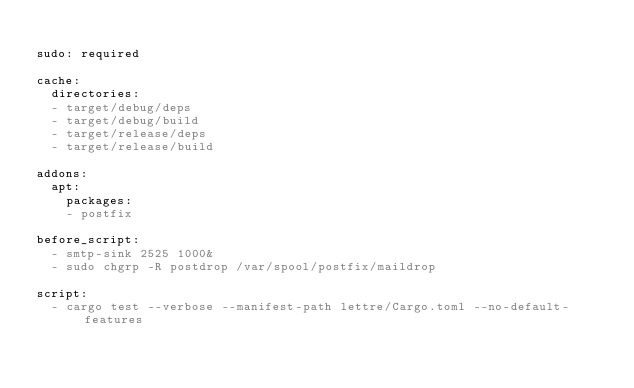Convert code to text. <code><loc_0><loc_0><loc_500><loc_500><_YAML_>
sudo: required

cache:
  directories:
  - target/debug/deps
  - target/debug/build
  - target/release/deps
  - target/release/build

addons:
  apt:
    packages:
    - postfix

before_script:
  - smtp-sink 2525 1000&
  - sudo chgrp -R postdrop /var/spool/postfix/maildrop

script:
  - cargo test --verbose --manifest-path lettre/Cargo.toml --no-default-features</code> 